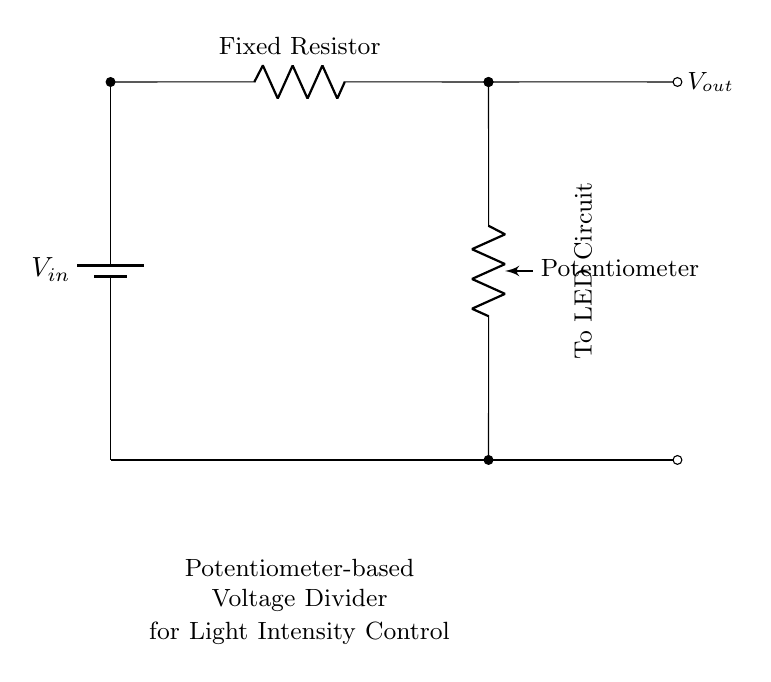What type of components are in this circuit? The circuit contains a battery, a fixed resistor, and a potentiometer, which are all essential components for creating a voltage divider.
Answer: battery, fixed resistor, potentiometer What is the function of the potentiometer in this circuit? The potentiometer serves as a variable resistor that allows for adjustment of the output voltage and thus the intensity of the light.
Answer: control light intensity What is the relationship between the input voltage and output voltage? The output voltage is a fraction of the input voltage determined by the resistances of the fixed resistor and the potentiometer, following the voltage divider rule.
Answer: direct relationship How many terminals does the potentiometer have? A standard potentiometer has three terminals: one for each end of the resistive track and one for the wiper (adjustable terminal).
Answer: three If the potentiometer is turned to its maximum resistance, what happens to the output voltage? When the potentiometer is at maximum resistance, most of the input voltage is dropped across the potentiometer, which lowers the output voltage significantly.
Answer: decreases How does adjusting the fixed resistor affect the circuit? Changing the value of the fixed resistor alters the total resistance in the circuit, which in turn affects the current and the voltage drop across the potentiometer, thereby affecting the output voltage level.
Answer: changes output voltage What is the purpose of the LED circuit connected to the output? The LED circuit uses the output voltage to determine the brightness of the LED, making it suitable for light intensity adjustments in cognitive testing environments.
Answer: illuminate LED 